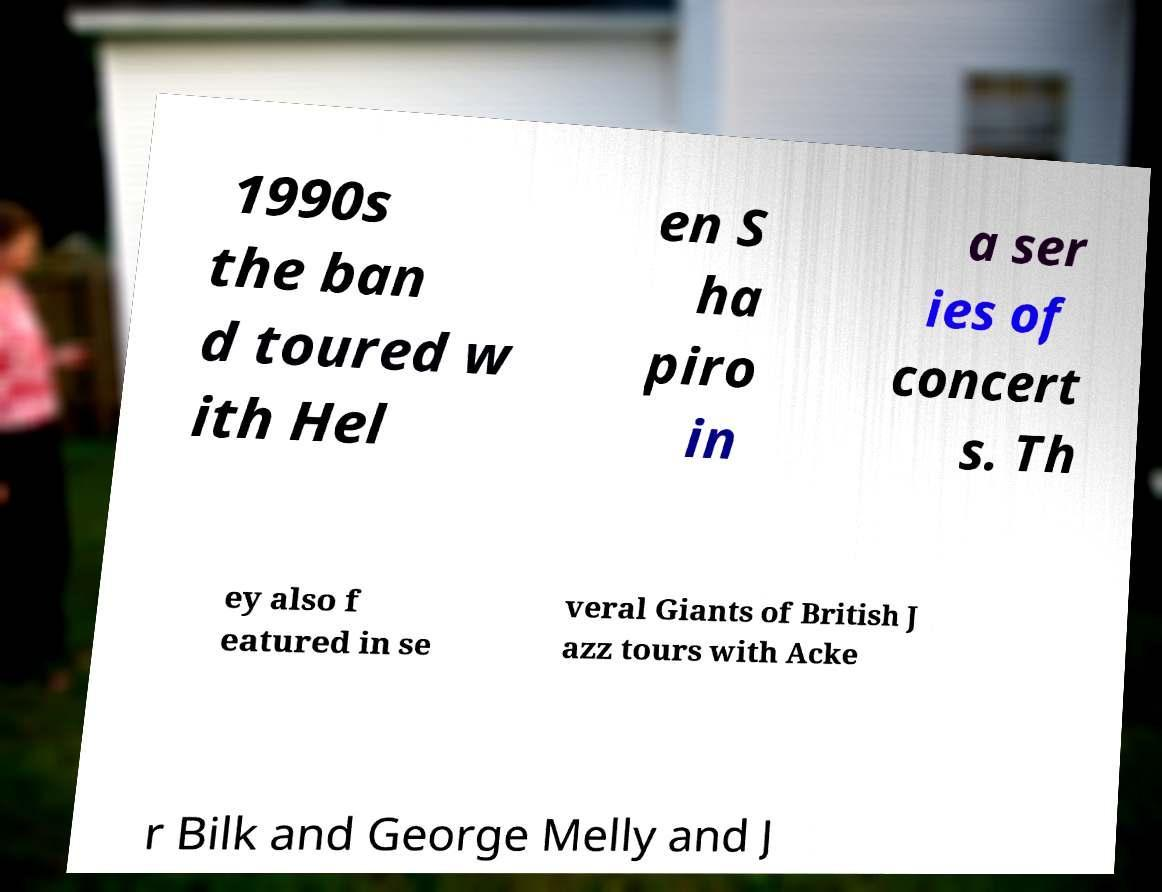For documentation purposes, I need the text within this image transcribed. Could you provide that? 1990s the ban d toured w ith Hel en S ha piro in a ser ies of concert s. Th ey also f eatured in se veral Giants of British J azz tours with Acke r Bilk and George Melly and J 